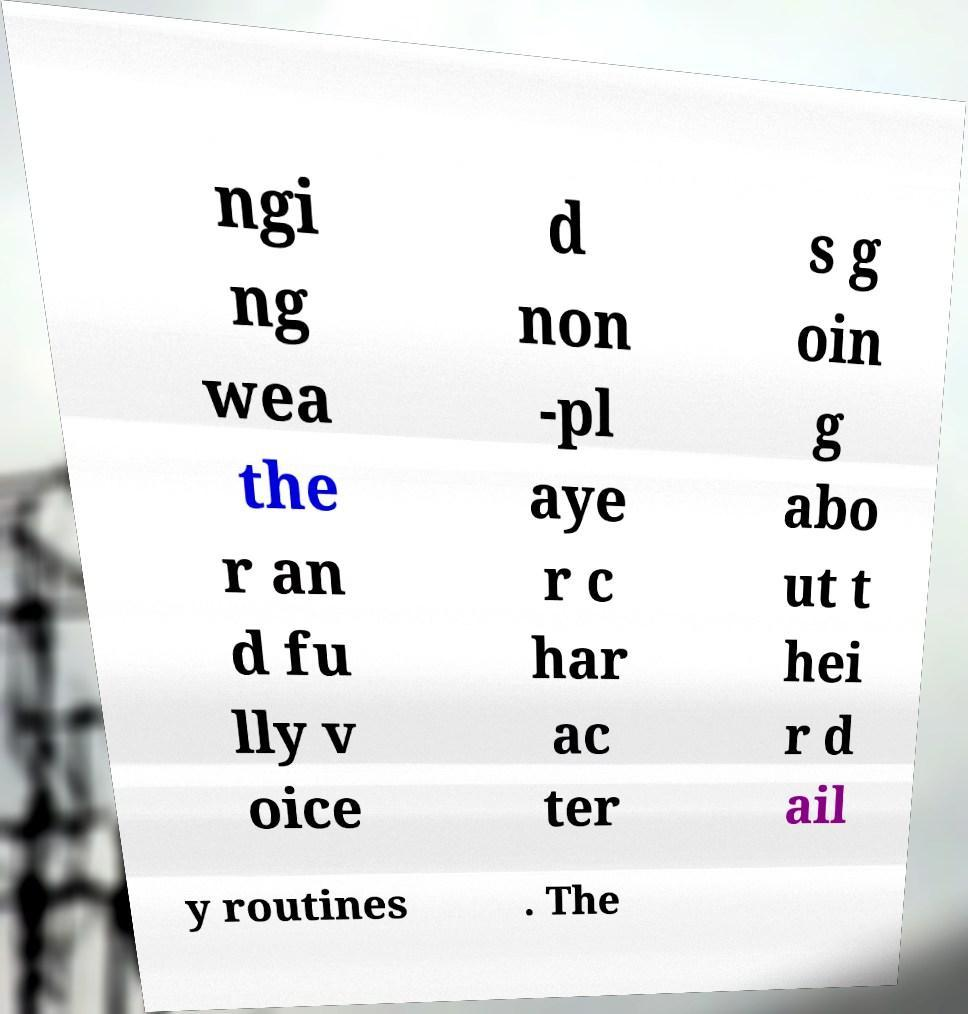Could you extract and type out the text from this image? ngi ng wea the r an d fu lly v oice d non -pl aye r c har ac ter s g oin g abo ut t hei r d ail y routines . The 